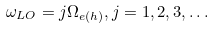Convert formula to latex. <formula><loc_0><loc_0><loc_500><loc_500>\omega _ { L O } = j \Omega _ { e ( h ) } , j = 1 , 2 , 3 , \dots</formula> 